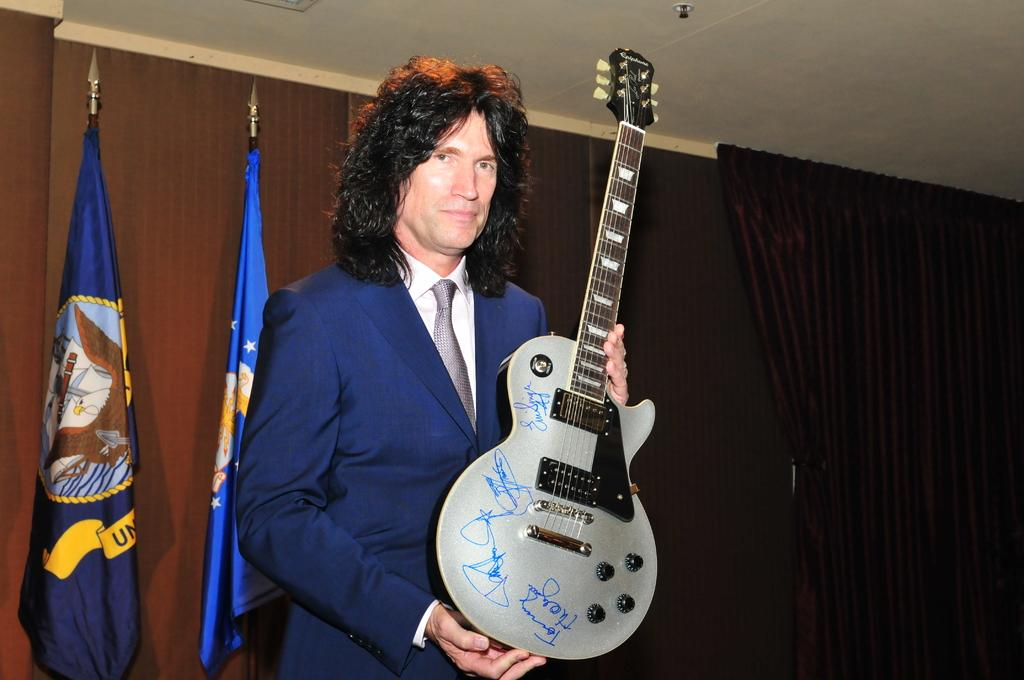Who is present in the image? There is a man in the image. What is the man wearing? The man is wearing a blue jacket. Can you describe the man's hair? The man has long hair. What is the man holding in the image? The man is holding a guitar. What can be seen behind the man in the image? There are two flags behind the man. Reasoning: Let'g: Let's think step by step in order to produce the conversation. We start by identifying the main subject in the image, which is the man. Then, we expand the conversation to include details about the man's clothing, hair, and what he is holding. Finally, we mention the background elements, which are the two flags. Each question is designed to elicit a specific detail about the image that is known from the provided facts. Absurd Question/Answer: What type of silver appliance is the man using in the image? There is no silver appliance present in the image. 